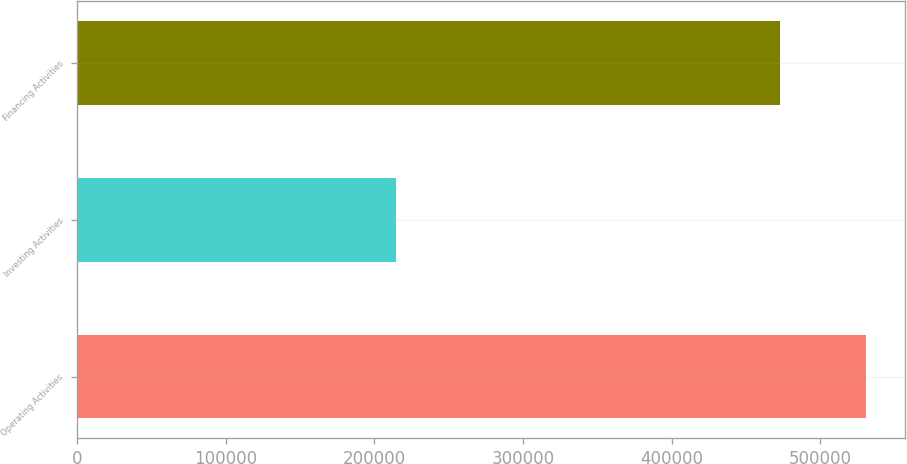Convert chart. <chart><loc_0><loc_0><loc_500><loc_500><bar_chart><fcel>Operating Activities<fcel>Investing Activities<fcel>Financing Activities<nl><fcel>530309<fcel>214334<fcel>472573<nl></chart> 